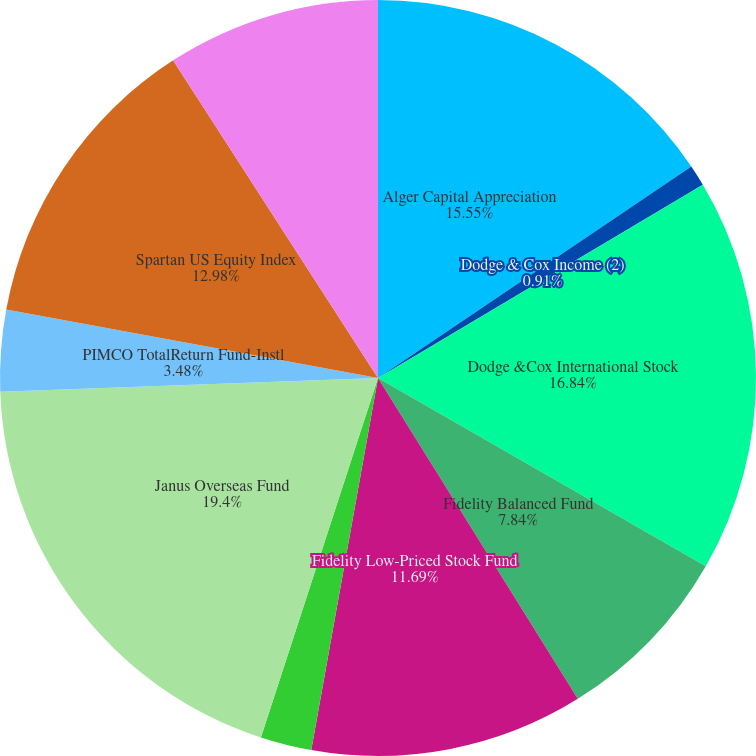Convert chart to OTSL. <chart><loc_0><loc_0><loc_500><loc_500><pie_chart><fcel>Alger Capital Appreciation<fcel>Dodge & Cox Income (2)<fcel>Dodge &Cox International Stock<fcel>Fidelity Balanced Fund<fcel>Fidelity Low-Priced Stock Fund<fcel>Fidelity Retirement Money<fcel>Janus Overseas Fund<fcel>PIMCO TotalReturn Fund-Instl<fcel>Spartan US Equity Index<fcel>T Rowe Price Equity Income (2)<nl><fcel>15.55%<fcel>0.91%<fcel>16.84%<fcel>7.84%<fcel>11.69%<fcel>2.19%<fcel>19.41%<fcel>3.48%<fcel>12.98%<fcel>9.12%<nl></chart> 